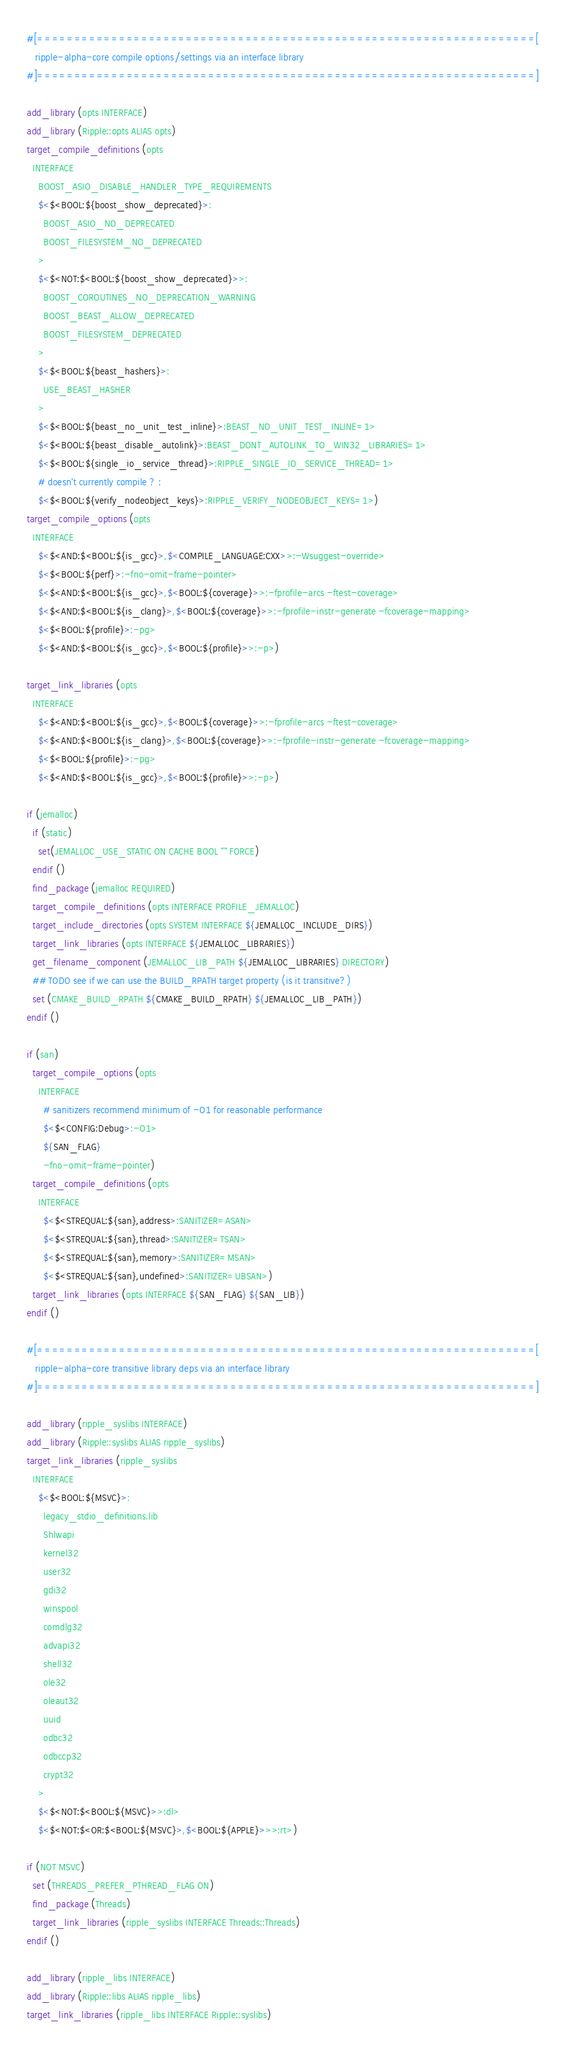Convert code to text. <code><loc_0><loc_0><loc_500><loc_500><_CMake_>#[===================================================================[
   ripple-alpha-core compile options/settings via an interface library
#]===================================================================]

add_library (opts INTERFACE)
add_library (Ripple::opts ALIAS opts)
target_compile_definitions (opts
  INTERFACE
    BOOST_ASIO_DISABLE_HANDLER_TYPE_REQUIREMENTS
    $<$<BOOL:${boost_show_deprecated}>:
      BOOST_ASIO_NO_DEPRECATED
      BOOST_FILESYSTEM_NO_DEPRECATED
    >
    $<$<NOT:$<BOOL:${boost_show_deprecated}>>:
      BOOST_COROUTINES_NO_DEPRECATION_WARNING
      BOOST_BEAST_ALLOW_DEPRECATED
      BOOST_FILESYSTEM_DEPRECATED
    >
    $<$<BOOL:${beast_hashers}>:
      USE_BEAST_HASHER
    >
    $<$<BOOL:${beast_no_unit_test_inline}>:BEAST_NO_UNIT_TEST_INLINE=1>
    $<$<BOOL:${beast_disable_autolink}>:BEAST_DONT_AUTOLINK_TO_WIN32_LIBRARIES=1>
    $<$<BOOL:${single_io_service_thread}>:RIPPLE_SINGLE_IO_SERVICE_THREAD=1>
    # doesn't currently compile ? :
    $<$<BOOL:${verify_nodeobject_keys}>:RIPPLE_VERIFY_NODEOBJECT_KEYS=1>)
target_compile_options (opts
  INTERFACE
    $<$<AND:$<BOOL:${is_gcc}>,$<COMPILE_LANGUAGE:CXX>>:-Wsuggest-override>
    $<$<BOOL:${perf}>:-fno-omit-frame-pointer>
    $<$<AND:$<BOOL:${is_gcc}>,$<BOOL:${coverage}>>:-fprofile-arcs -ftest-coverage>
    $<$<AND:$<BOOL:${is_clang}>,$<BOOL:${coverage}>>:-fprofile-instr-generate -fcoverage-mapping>
    $<$<BOOL:${profile}>:-pg>
    $<$<AND:$<BOOL:${is_gcc}>,$<BOOL:${profile}>>:-p>)

target_link_libraries (opts
  INTERFACE
    $<$<AND:$<BOOL:${is_gcc}>,$<BOOL:${coverage}>>:-fprofile-arcs -ftest-coverage>
    $<$<AND:$<BOOL:${is_clang}>,$<BOOL:${coverage}>>:-fprofile-instr-generate -fcoverage-mapping>
    $<$<BOOL:${profile}>:-pg>
    $<$<AND:$<BOOL:${is_gcc}>,$<BOOL:${profile}>>:-p>)

if (jemalloc)
  if (static)
    set(JEMALLOC_USE_STATIC ON CACHE BOOL "" FORCE)
  endif ()
  find_package (jemalloc REQUIRED)
  target_compile_definitions (opts INTERFACE PROFILE_JEMALLOC)
  target_include_directories (opts SYSTEM INTERFACE ${JEMALLOC_INCLUDE_DIRS})
  target_link_libraries (opts INTERFACE ${JEMALLOC_LIBRARIES})
  get_filename_component (JEMALLOC_LIB_PATH ${JEMALLOC_LIBRARIES} DIRECTORY)
  ## TODO see if we can use the BUILD_RPATH target property (is it transitive?)
  set (CMAKE_BUILD_RPATH ${CMAKE_BUILD_RPATH} ${JEMALLOC_LIB_PATH})
endif ()

if (san)
  target_compile_options (opts
    INTERFACE
      # sanitizers recommend minimum of -O1 for reasonable performance
      $<$<CONFIG:Debug>:-O1>
      ${SAN_FLAG}
      -fno-omit-frame-pointer)
  target_compile_definitions (opts
    INTERFACE
      $<$<STREQUAL:${san},address>:SANITIZER=ASAN>
      $<$<STREQUAL:${san},thread>:SANITIZER=TSAN>
      $<$<STREQUAL:${san},memory>:SANITIZER=MSAN>
      $<$<STREQUAL:${san},undefined>:SANITIZER=UBSAN>)
  target_link_libraries (opts INTERFACE ${SAN_FLAG} ${SAN_LIB})
endif ()

#[===================================================================[
   ripple-alpha-core transitive library deps via an interface library
#]===================================================================]

add_library (ripple_syslibs INTERFACE)
add_library (Ripple::syslibs ALIAS ripple_syslibs)
target_link_libraries (ripple_syslibs
  INTERFACE
    $<$<BOOL:${MSVC}>:
      legacy_stdio_definitions.lib
      Shlwapi
      kernel32
      user32
      gdi32
      winspool
      comdlg32
      advapi32
      shell32
      ole32
      oleaut32
      uuid
      odbc32
      odbccp32
      crypt32
    >
    $<$<NOT:$<BOOL:${MSVC}>>:dl>
    $<$<NOT:$<OR:$<BOOL:${MSVC}>,$<BOOL:${APPLE}>>>:rt>)

if (NOT MSVC)
  set (THREADS_PREFER_PTHREAD_FLAG ON)
  find_package (Threads)
  target_link_libraries (ripple_syslibs INTERFACE Threads::Threads)
endif ()

add_library (ripple_libs INTERFACE)
add_library (Ripple::libs ALIAS ripple_libs)
target_link_libraries (ripple_libs INTERFACE Ripple::syslibs)
</code> 